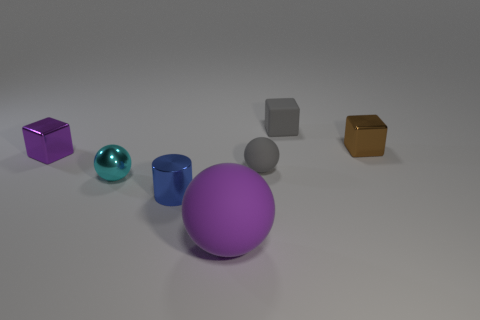Subtract all gray matte cubes. How many cubes are left? 2 Subtract all cyan spheres. How many spheres are left? 2 Add 2 big purple objects. How many objects exist? 9 Subtract all blocks. How many objects are left? 4 Subtract 2 cubes. How many cubes are left? 1 Subtract 0 cyan cylinders. How many objects are left? 7 Subtract all red cylinders. Subtract all red cubes. How many cylinders are left? 1 Subtract all red cylinders. How many blue balls are left? 0 Subtract all small shiny things. Subtract all big green cylinders. How many objects are left? 3 Add 3 cubes. How many cubes are left? 6 